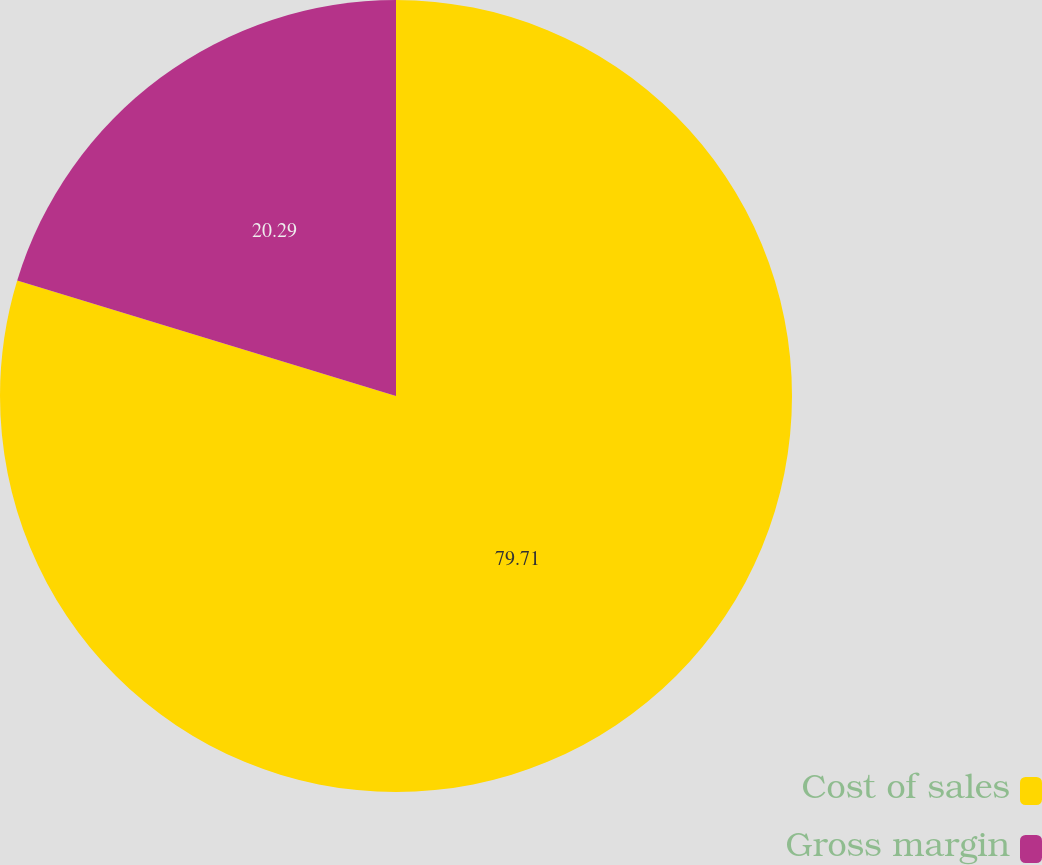Convert chart. <chart><loc_0><loc_0><loc_500><loc_500><pie_chart><fcel>Cost of sales<fcel>Gross margin<nl><fcel>79.71%<fcel>20.29%<nl></chart> 